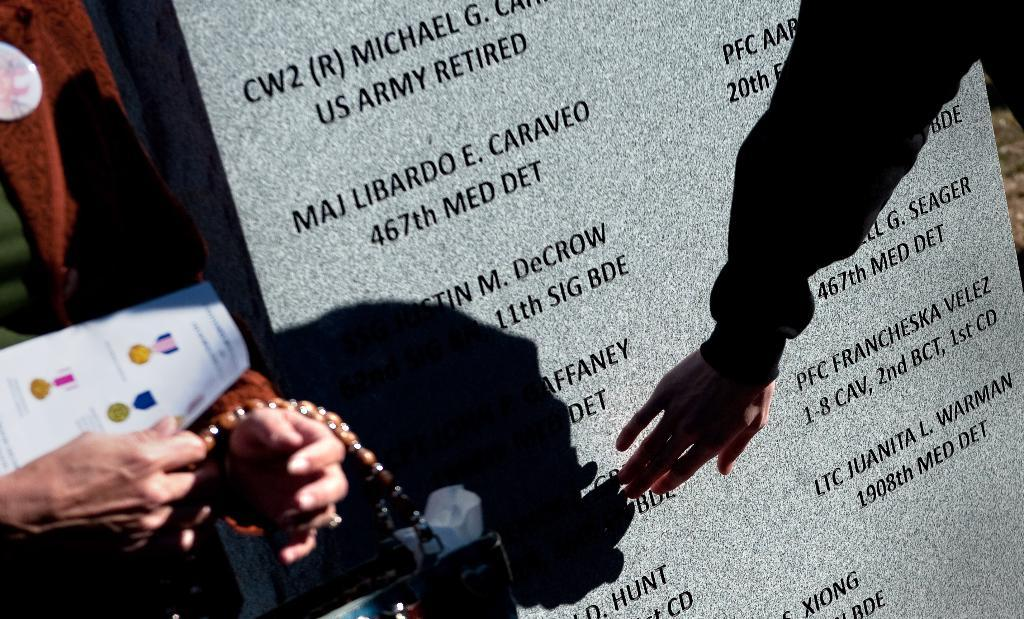What body part can be seen in the image? Human hands are visible in the image. What type of jewelry is present in the image? There is a neck chain in the image. What type of object is made of paper in the image? There is a paper in the image. What material is the stone in the image made of? The stone in the image is made of marble. What is written or engraved on the marble stone? There is text on the marble stone. How many sisters are present in the image? There are no sisters present in the image. What season is depicted in the image? The image does not depict a season; it contains human hands, a neck chain, a paper, a marble stone with text, and no reference to a season. 